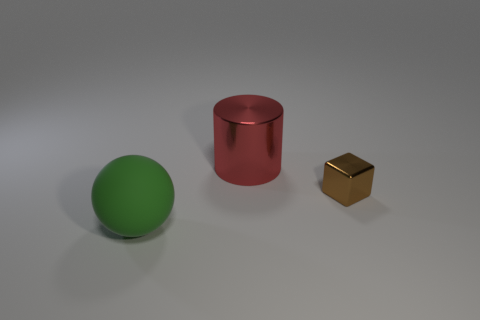Add 3 tiny red matte blocks. How many objects exist? 6 Subtract all spheres. How many objects are left? 2 Subtract 0 cyan spheres. How many objects are left? 3 Subtract all tiny red things. Subtract all brown blocks. How many objects are left? 2 Add 1 tiny metallic things. How many tiny metallic things are left? 2 Add 3 large green rubber balls. How many large green rubber balls exist? 4 